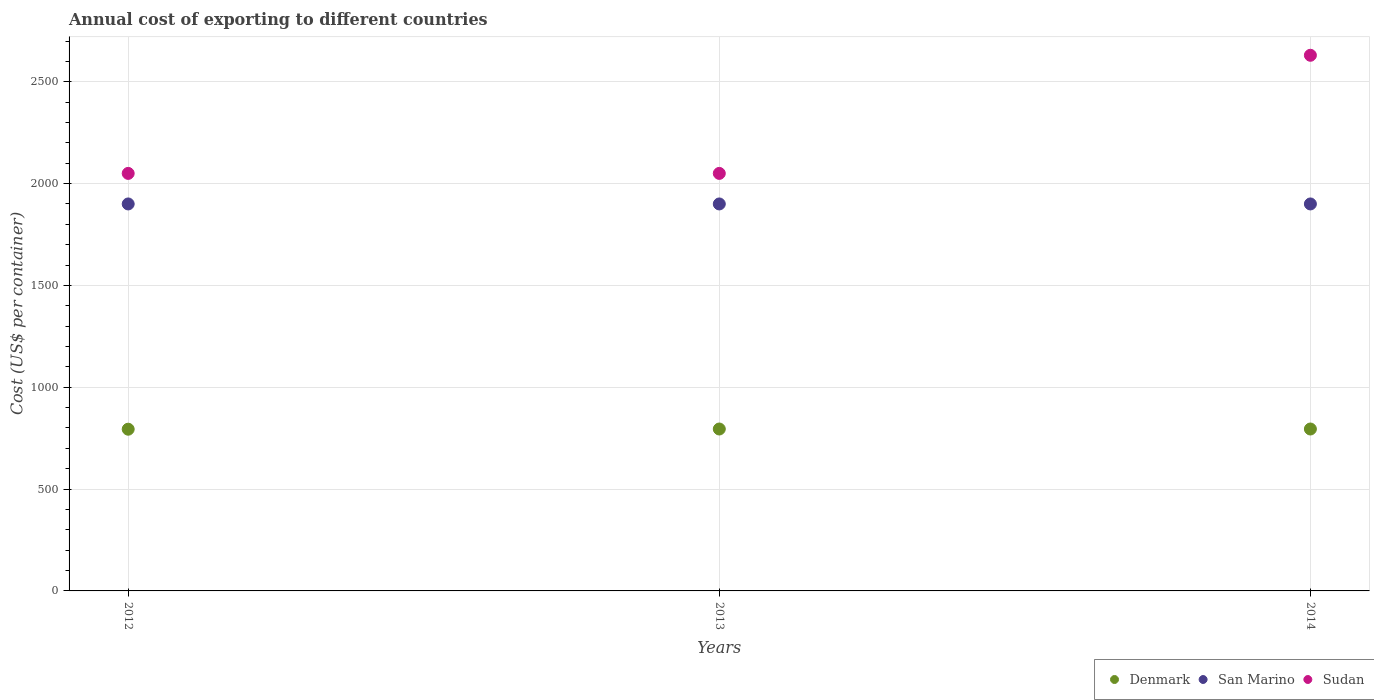What is the total annual cost of exporting in Sudan in 2012?
Keep it short and to the point. 2050. Across all years, what is the maximum total annual cost of exporting in San Marino?
Give a very brief answer. 1900. Across all years, what is the minimum total annual cost of exporting in Sudan?
Your answer should be compact. 2050. In which year was the total annual cost of exporting in San Marino maximum?
Make the answer very short. 2012. What is the total total annual cost of exporting in Denmark in the graph?
Your answer should be compact. 2384. What is the difference between the total annual cost of exporting in Denmark in 2013 and that in 2014?
Your response must be concise. 0. What is the difference between the total annual cost of exporting in Denmark in 2013 and the total annual cost of exporting in Sudan in 2012?
Offer a terse response. -1255. What is the average total annual cost of exporting in Denmark per year?
Give a very brief answer. 794.67. In the year 2014, what is the difference between the total annual cost of exporting in San Marino and total annual cost of exporting in Sudan?
Your response must be concise. -730. In how many years, is the total annual cost of exporting in Sudan greater than 1800 US$?
Your response must be concise. 3. What is the ratio of the total annual cost of exporting in San Marino in 2013 to that in 2014?
Your response must be concise. 1. Is the difference between the total annual cost of exporting in San Marino in 2013 and 2014 greater than the difference between the total annual cost of exporting in Sudan in 2013 and 2014?
Provide a short and direct response. Yes. What is the difference between the highest and the second highest total annual cost of exporting in Sudan?
Ensure brevity in your answer.  580. In how many years, is the total annual cost of exporting in Sudan greater than the average total annual cost of exporting in Sudan taken over all years?
Provide a short and direct response. 1. Is the sum of the total annual cost of exporting in Sudan in 2012 and 2014 greater than the maximum total annual cost of exporting in Denmark across all years?
Provide a short and direct response. Yes. Does the total annual cost of exporting in Sudan monotonically increase over the years?
Offer a terse response. No. How many dotlines are there?
Ensure brevity in your answer.  3. How many years are there in the graph?
Provide a succinct answer. 3. What is the difference between two consecutive major ticks on the Y-axis?
Provide a short and direct response. 500. Are the values on the major ticks of Y-axis written in scientific E-notation?
Keep it short and to the point. No. Does the graph contain any zero values?
Your answer should be compact. No. Does the graph contain grids?
Provide a short and direct response. Yes. Where does the legend appear in the graph?
Give a very brief answer. Bottom right. How many legend labels are there?
Your response must be concise. 3. What is the title of the graph?
Your answer should be very brief. Annual cost of exporting to different countries. Does "French Polynesia" appear as one of the legend labels in the graph?
Make the answer very short. No. What is the label or title of the X-axis?
Your response must be concise. Years. What is the label or title of the Y-axis?
Keep it short and to the point. Cost (US$ per container). What is the Cost (US$ per container) of Denmark in 2012?
Keep it short and to the point. 794. What is the Cost (US$ per container) of San Marino in 2012?
Your answer should be compact. 1900. What is the Cost (US$ per container) of Sudan in 2012?
Keep it short and to the point. 2050. What is the Cost (US$ per container) in Denmark in 2013?
Provide a succinct answer. 795. What is the Cost (US$ per container) in San Marino in 2013?
Your response must be concise. 1900. What is the Cost (US$ per container) in Sudan in 2013?
Offer a terse response. 2050. What is the Cost (US$ per container) of Denmark in 2014?
Offer a very short reply. 795. What is the Cost (US$ per container) of San Marino in 2014?
Your answer should be compact. 1900. What is the Cost (US$ per container) in Sudan in 2014?
Provide a short and direct response. 2630. Across all years, what is the maximum Cost (US$ per container) of Denmark?
Give a very brief answer. 795. Across all years, what is the maximum Cost (US$ per container) of San Marino?
Keep it short and to the point. 1900. Across all years, what is the maximum Cost (US$ per container) of Sudan?
Provide a short and direct response. 2630. Across all years, what is the minimum Cost (US$ per container) in Denmark?
Offer a very short reply. 794. Across all years, what is the minimum Cost (US$ per container) in San Marino?
Your response must be concise. 1900. Across all years, what is the minimum Cost (US$ per container) of Sudan?
Make the answer very short. 2050. What is the total Cost (US$ per container) of Denmark in the graph?
Your answer should be very brief. 2384. What is the total Cost (US$ per container) in San Marino in the graph?
Ensure brevity in your answer.  5700. What is the total Cost (US$ per container) in Sudan in the graph?
Ensure brevity in your answer.  6730. What is the difference between the Cost (US$ per container) of San Marino in 2012 and that in 2013?
Keep it short and to the point. 0. What is the difference between the Cost (US$ per container) in Sudan in 2012 and that in 2013?
Your response must be concise. 0. What is the difference between the Cost (US$ per container) in Denmark in 2012 and that in 2014?
Provide a succinct answer. -1. What is the difference between the Cost (US$ per container) in San Marino in 2012 and that in 2014?
Make the answer very short. 0. What is the difference between the Cost (US$ per container) of Sudan in 2012 and that in 2014?
Your answer should be very brief. -580. What is the difference between the Cost (US$ per container) in Denmark in 2013 and that in 2014?
Your answer should be compact. 0. What is the difference between the Cost (US$ per container) in San Marino in 2013 and that in 2014?
Give a very brief answer. 0. What is the difference between the Cost (US$ per container) in Sudan in 2013 and that in 2014?
Your response must be concise. -580. What is the difference between the Cost (US$ per container) in Denmark in 2012 and the Cost (US$ per container) in San Marino in 2013?
Ensure brevity in your answer.  -1106. What is the difference between the Cost (US$ per container) in Denmark in 2012 and the Cost (US$ per container) in Sudan in 2013?
Your answer should be compact. -1256. What is the difference between the Cost (US$ per container) in San Marino in 2012 and the Cost (US$ per container) in Sudan in 2013?
Provide a succinct answer. -150. What is the difference between the Cost (US$ per container) of Denmark in 2012 and the Cost (US$ per container) of San Marino in 2014?
Ensure brevity in your answer.  -1106. What is the difference between the Cost (US$ per container) in Denmark in 2012 and the Cost (US$ per container) in Sudan in 2014?
Offer a very short reply. -1836. What is the difference between the Cost (US$ per container) of San Marino in 2012 and the Cost (US$ per container) of Sudan in 2014?
Provide a succinct answer. -730. What is the difference between the Cost (US$ per container) in Denmark in 2013 and the Cost (US$ per container) in San Marino in 2014?
Offer a very short reply. -1105. What is the difference between the Cost (US$ per container) in Denmark in 2013 and the Cost (US$ per container) in Sudan in 2014?
Your response must be concise. -1835. What is the difference between the Cost (US$ per container) of San Marino in 2013 and the Cost (US$ per container) of Sudan in 2014?
Provide a succinct answer. -730. What is the average Cost (US$ per container) of Denmark per year?
Offer a very short reply. 794.67. What is the average Cost (US$ per container) of San Marino per year?
Offer a terse response. 1900. What is the average Cost (US$ per container) in Sudan per year?
Give a very brief answer. 2243.33. In the year 2012, what is the difference between the Cost (US$ per container) in Denmark and Cost (US$ per container) in San Marino?
Make the answer very short. -1106. In the year 2012, what is the difference between the Cost (US$ per container) in Denmark and Cost (US$ per container) in Sudan?
Provide a short and direct response. -1256. In the year 2012, what is the difference between the Cost (US$ per container) of San Marino and Cost (US$ per container) of Sudan?
Give a very brief answer. -150. In the year 2013, what is the difference between the Cost (US$ per container) of Denmark and Cost (US$ per container) of San Marino?
Your answer should be compact. -1105. In the year 2013, what is the difference between the Cost (US$ per container) of Denmark and Cost (US$ per container) of Sudan?
Your response must be concise. -1255. In the year 2013, what is the difference between the Cost (US$ per container) of San Marino and Cost (US$ per container) of Sudan?
Your answer should be compact. -150. In the year 2014, what is the difference between the Cost (US$ per container) in Denmark and Cost (US$ per container) in San Marino?
Make the answer very short. -1105. In the year 2014, what is the difference between the Cost (US$ per container) in Denmark and Cost (US$ per container) in Sudan?
Your answer should be compact. -1835. In the year 2014, what is the difference between the Cost (US$ per container) in San Marino and Cost (US$ per container) in Sudan?
Provide a succinct answer. -730. What is the ratio of the Cost (US$ per container) in Denmark in 2012 to that in 2014?
Keep it short and to the point. 1. What is the ratio of the Cost (US$ per container) in San Marino in 2012 to that in 2014?
Your response must be concise. 1. What is the ratio of the Cost (US$ per container) in Sudan in 2012 to that in 2014?
Keep it short and to the point. 0.78. What is the ratio of the Cost (US$ per container) of Denmark in 2013 to that in 2014?
Ensure brevity in your answer.  1. What is the ratio of the Cost (US$ per container) in Sudan in 2013 to that in 2014?
Your response must be concise. 0.78. What is the difference between the highest and the second highest Cost (US$ per container) of San Marino?
Your answer should be compact. 0. What is the difference between the highest and the second highest Cost (US$ per container) in Sudan?
Keep it short and to the point. 580. What is the difference between the highest and the lowest Cost (US$ per container) in San Marino?
Offer a very short reply. 0. What is the difference between the highest and the lowest Cost (US$ per container) of Sudan?
Give a very brief answer. 580. 